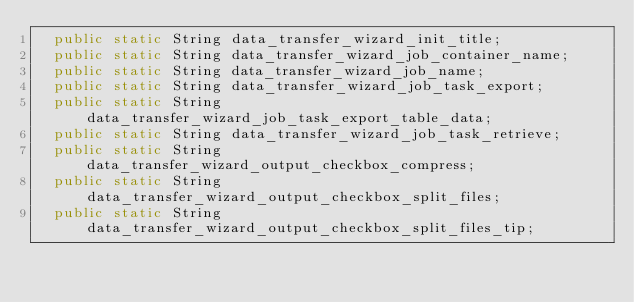Convert code to text. <code><loc_0><loc_0><loc_500><loc_500><_Java_>	public static String data_transfer_wizard_init_title;
	public static String data_transfer_wizard_job_container_name;
	public static String data_transfer_wizard_job_name;
	public static String data_transfer_wizard_job_task_export;
	public static String data_transfer_wizard_job_task_export_table_data;
	public static String data_transfer_wizard_job_task_retrieve;
	public static String data_transfer_wizard_output_checkbox_compress;
	public static String data_transfer_wizard_output_checkbox_split_files;
	public static String data_transfer_wizard_output_checkbox_split_files_tip;</code> 